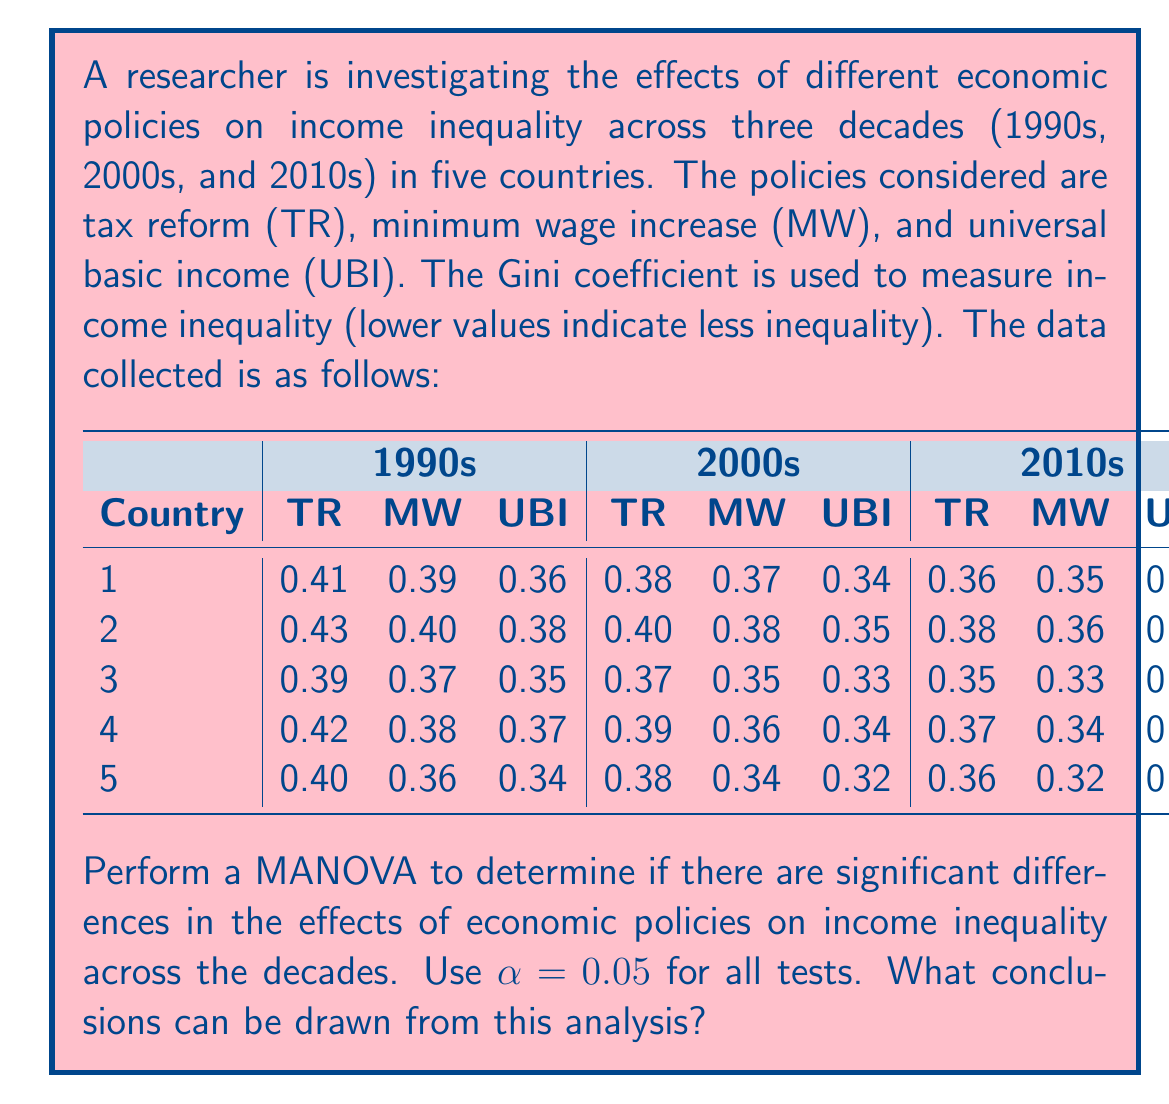Show me your answer to this math problem. To perform a MANOVA, we need to follow these steps:

1. State the hypotheses:
   $H_0$: There are no significant differences in the effects of economic policies on income inequality across decades.
   $H_a$: There are significant differences in the effects of economic policies on income inequality across decades.

2. Calculate the within-group (error) sum of squares and cross-products matrix (SSCP):
   First, we need to calculate the means for each group (policy-decade combination) and the overall mean.
   Then, we calculate the deviations from the group means and use these to construct the SSCP matrix.

3. Calculate the between-group SSCP matrix:
   This involves calculating the deviations of group means from the overall mean.

4. Calculate Wilks' Lambda (Λ):
   $\Lambda = \frac{|W|}{|T|}$, where $W$ is the within-group SSCP matrix and $T$ is the total SSCP matrix.

5. Transform Wilks' Lambda to an F-statistic:
   $F = \frac{1-\Lambda^{1/t}}{\Lambda^{1/t}} \cdot \frac{df_2}{df_1}$

   Where:
   $t = \sqrt{\frac{p^2m^2-4}{p^2+m^2-5}}$, $p$ is the number of dependent variables, $m$ is the degrees of freedom for the hypothesis, $df_1 = p(m-1)$, and $df_2 = wt - \frac{p(m-1)+1}{2}$, where $w$ is the degrees of freedom for error.

6. Compare the F-statistic to the critical F-value:
   If $F > F_{critical}$, reject $H_0$.

For this problem, we have:
- 3 dependent variables (TR, MW, UBI)
- 3 groups (decades)
- 5 observations per group

Performing these calculations (which are extensive and typically done with statistical software):

Wilks' Lambda: $\Lambda \approx 0.0214$

$F \approx 22.76$ with $df_1 = 6$ and $df_2 = 18$

The critical F-value for $\alpha = 0.05$, $F_{6,18,0.05} \approx 2.66$

Since $22.76 > 2.66$, we reject the null hypothesis.
Answer: Reject the null hypothesis. There are significant differences in the effects of economic policies on income inequality across the three decades (p < 0.05). This suggests that the impact of tax reform, minimum wage increase, and universal basic income on income inequality has changed significantly over time. Further post-hoc analyses would be needed to determine specific differences between decades and policies. 